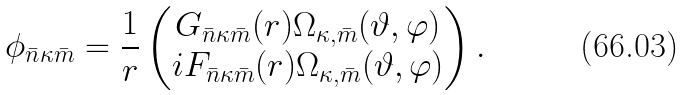Convert formula to latex. <formula><loc_0><loc_0><loc_500><loc_500>\phi _ { \bar { n } \kappa \bar { m } } = \frac { 1 } { r } \begin{pmatrix} G _ { \bar { n } \kappa \bar { m } } ( r ) \Omega _ { \kappa , \bar { m } } ( \vartheta , \varphi ) \\ i F _ { \bar { n } \kappa \bar { m } } ( r ) \Omega _ { \kappa , \bar { m } } ( \vartheta , \varphi ) \end{pmatrix} .</formula> 